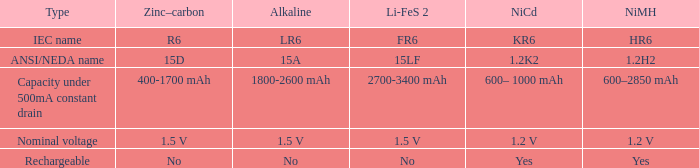What is li-fes 2, when category is nominal voltage? 1.5 V. 